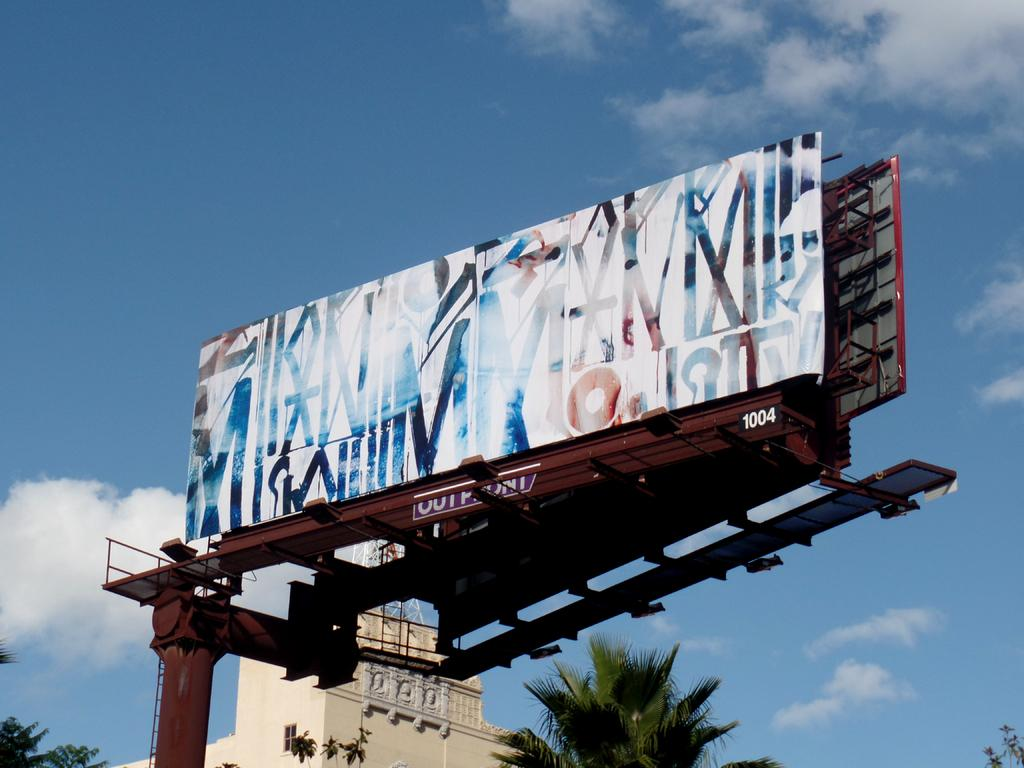<image>
Share a concise interpretation of the image provided. The billboard is labeled with the number 1004. 